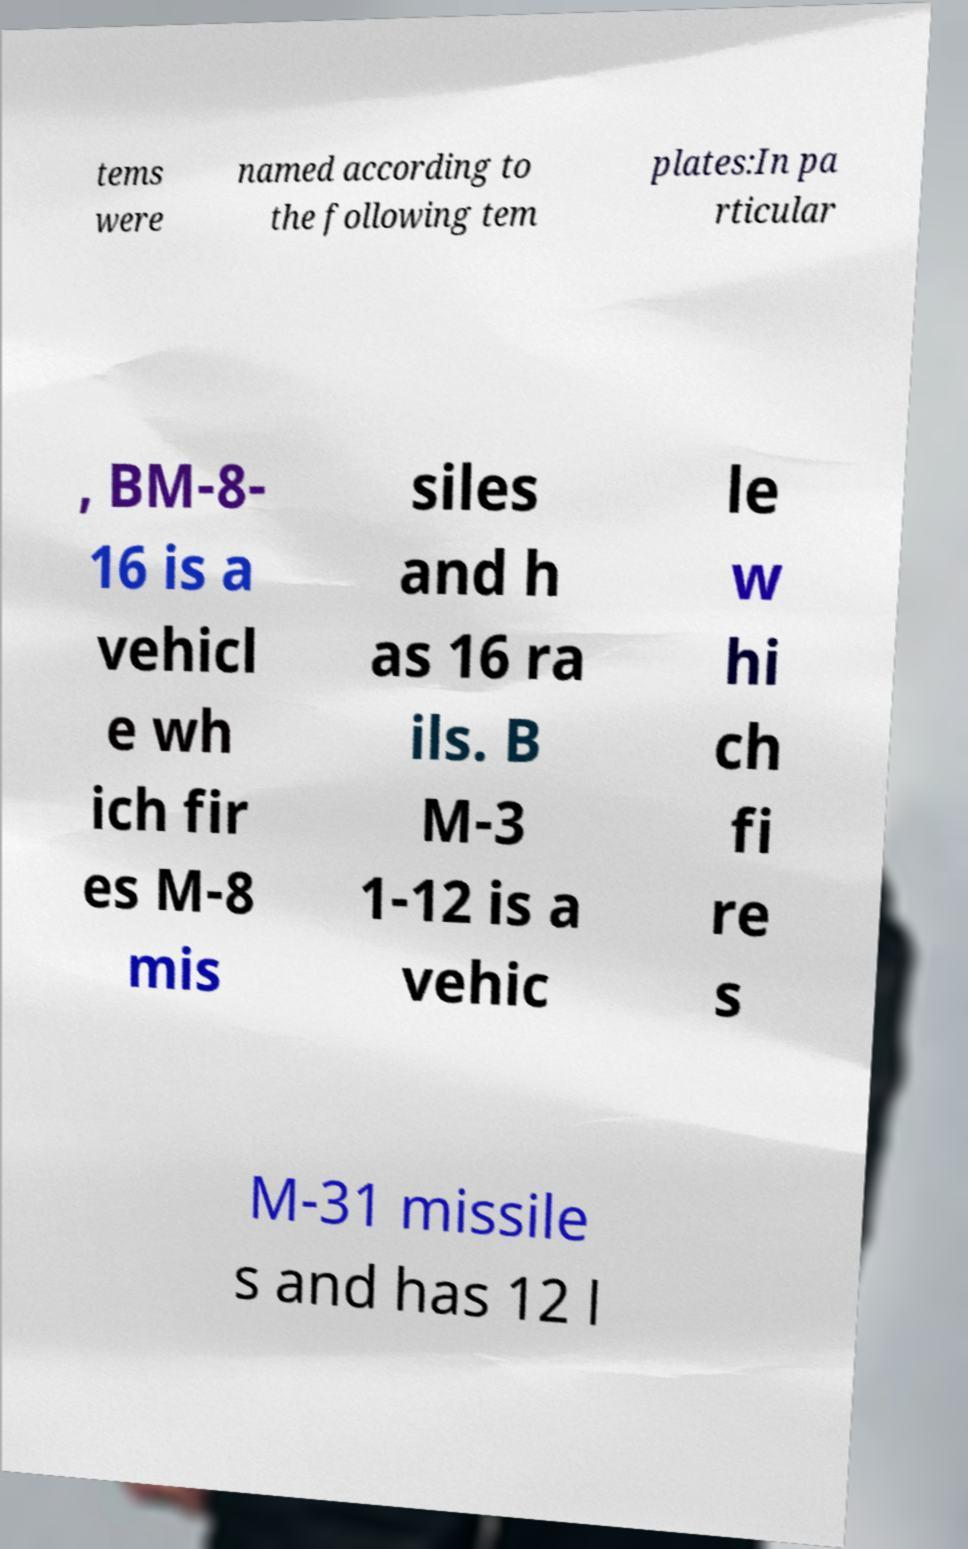For documentation purposes, I need the text within this image transcribed. Could you provide that? tems were named according to the following tem plates:In pa rticular , BM-8- 16 is a vehicl e wh ich fir es M-8 mis siles and h as 16 ra ils. B M-3 1-12 is a vehic le w hi ch fi re s M-31 missile s and has 12 l 